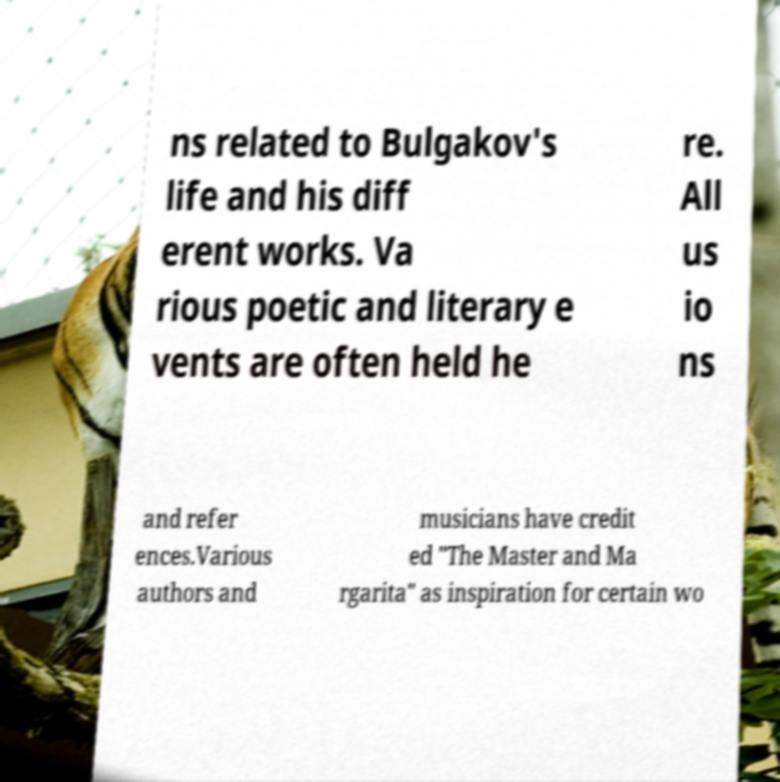Can you accurately transcribe the text from the provided image for me? ns related to Bulgakov's life and his diff erent works. Va rious poetic and literary e vents are often held he re. All us io ns and refer ences.Various authors and musicians have credit ed "The Master and Ma rgarita" as inspiration for certain wo 